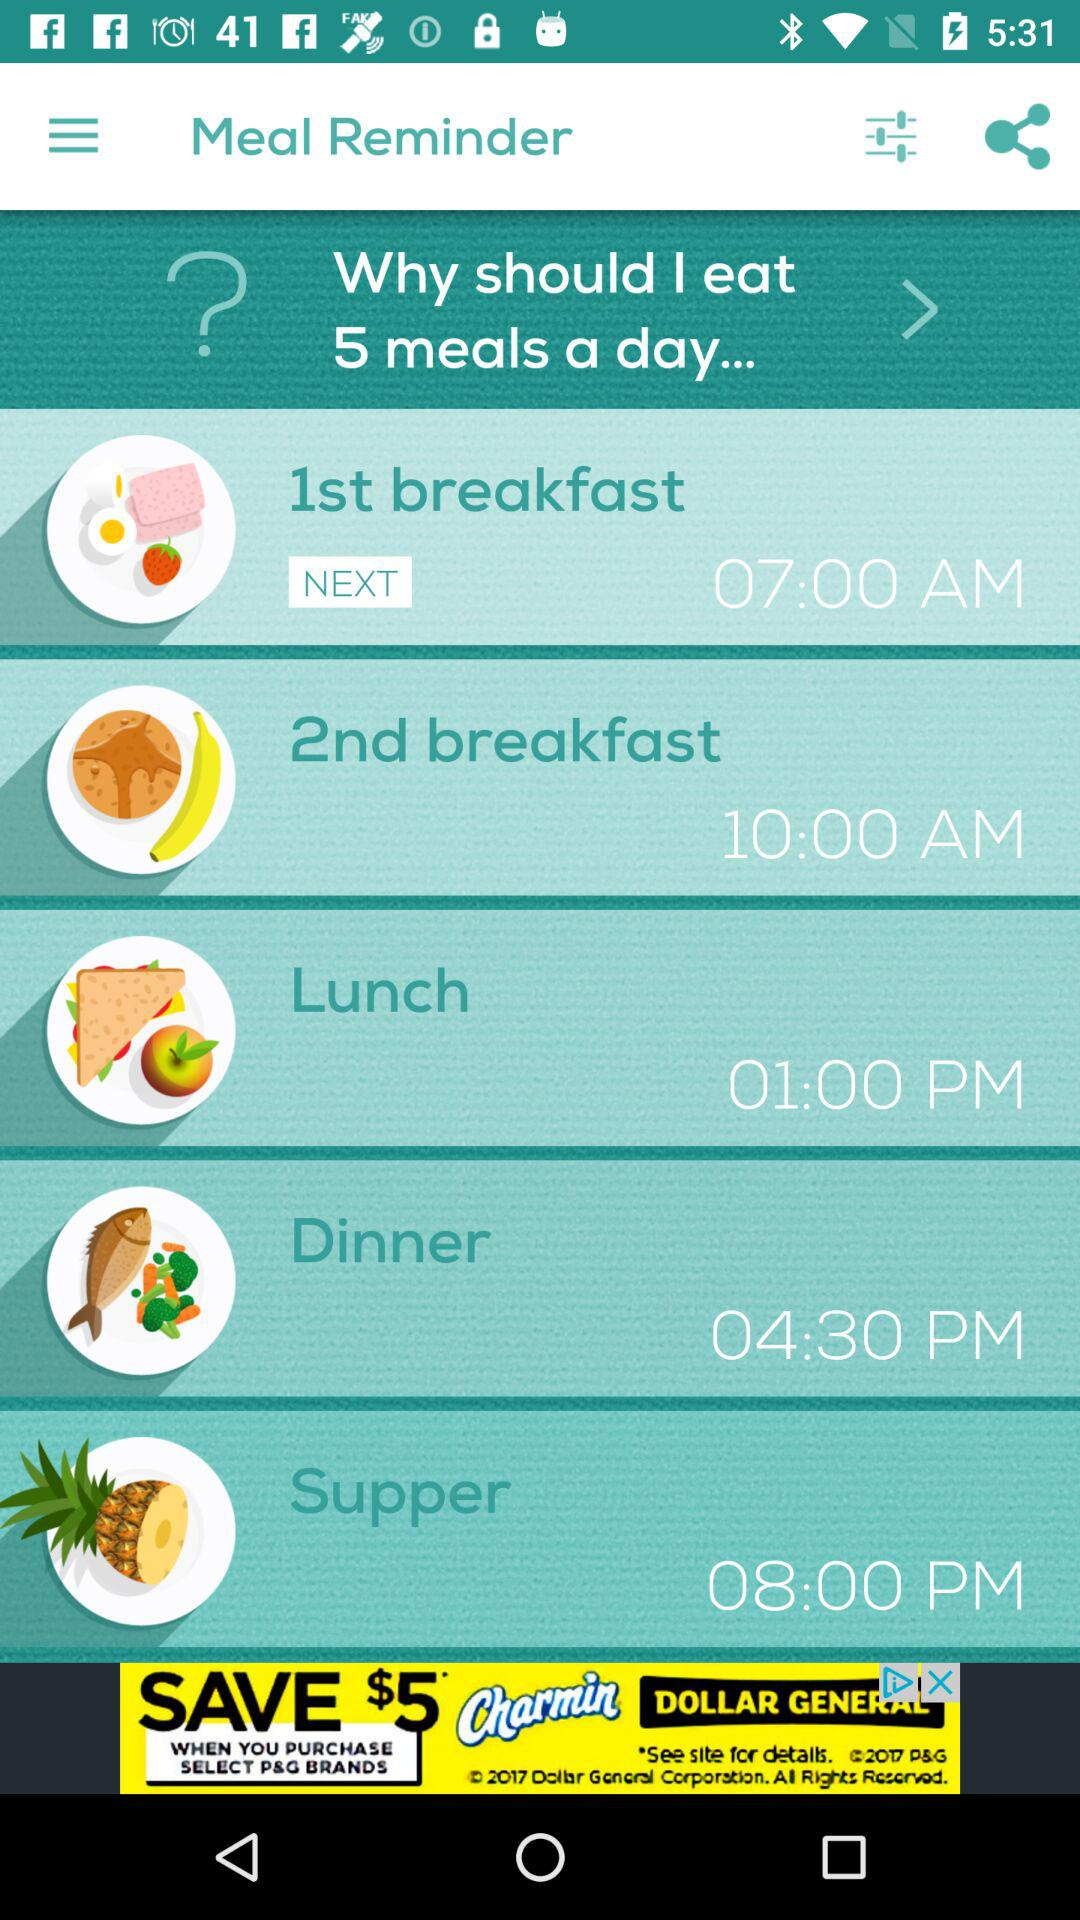How many meals are scheduled for the day?
Answer the question using a single word or phrase. 5 